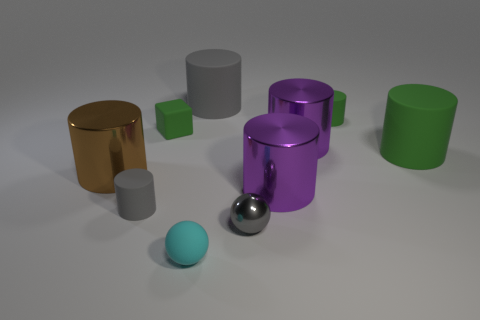Subtract all purple cylinders. How many cylinders are left? 5 Subtract all green matte cylinders. How many cylinders are left? 5 Subtract 4 cylinders. How many cylinders are left? 3 Subtract all brown cylinders. Subtract all brown balls. How many cylinders are left? 6 Subtract all blocks. How many objects are left? 9 Add 9 tiny rubber balls. How many tiny rubber balls are left? 10 Add 4 small objects. How many small objects exist? 9 Subtract 0 yellow blocks. How many objects are left? 10 Subtract all big green rubber objects. Subtract all small gray metal spheres. How many objects are left? 8 